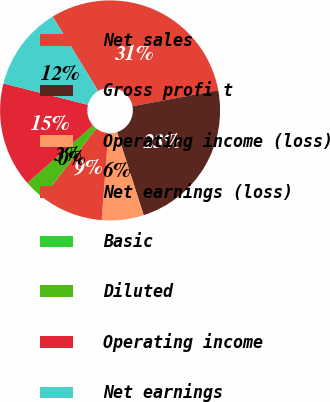Convert chart to OTSL. <chart><loc_0><loc_0><loc_500><loc_500><pie_chart><fcel>Net sales<fcel>Gross profi t<fcel>Operating income (loss)<fcel>Net earnings (loss)<fcel>Basic<fcel>Diluted<fcel>Operating income<fcel>Net earnings<nl><fcel>30.8%<fcel>22.99%<fcel>6.16%<fcel>9.24%<fcel>0.0%<fcel>3.08%<fcel>15.4%<fcel>12.32%<nl></chart> 